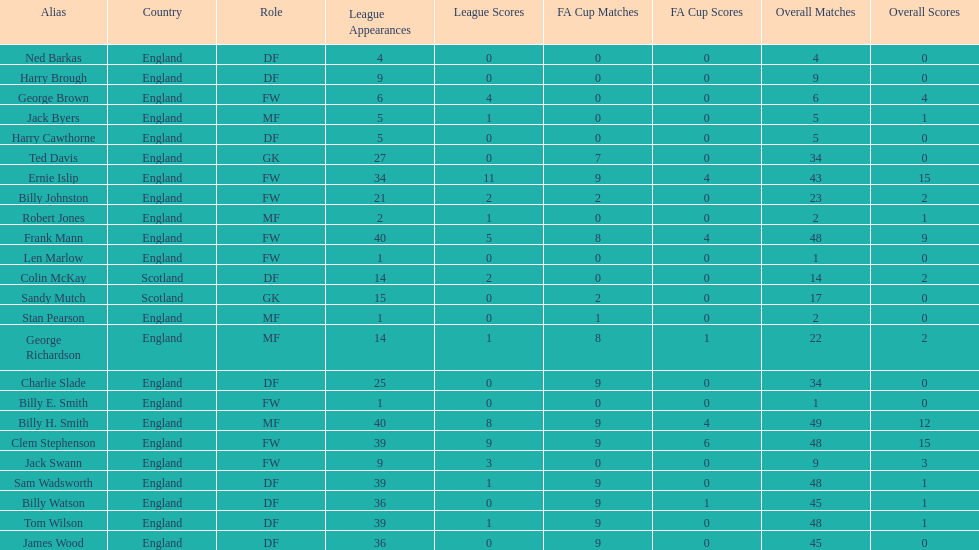Which position is listed the least amount of times on this chart? GK. 